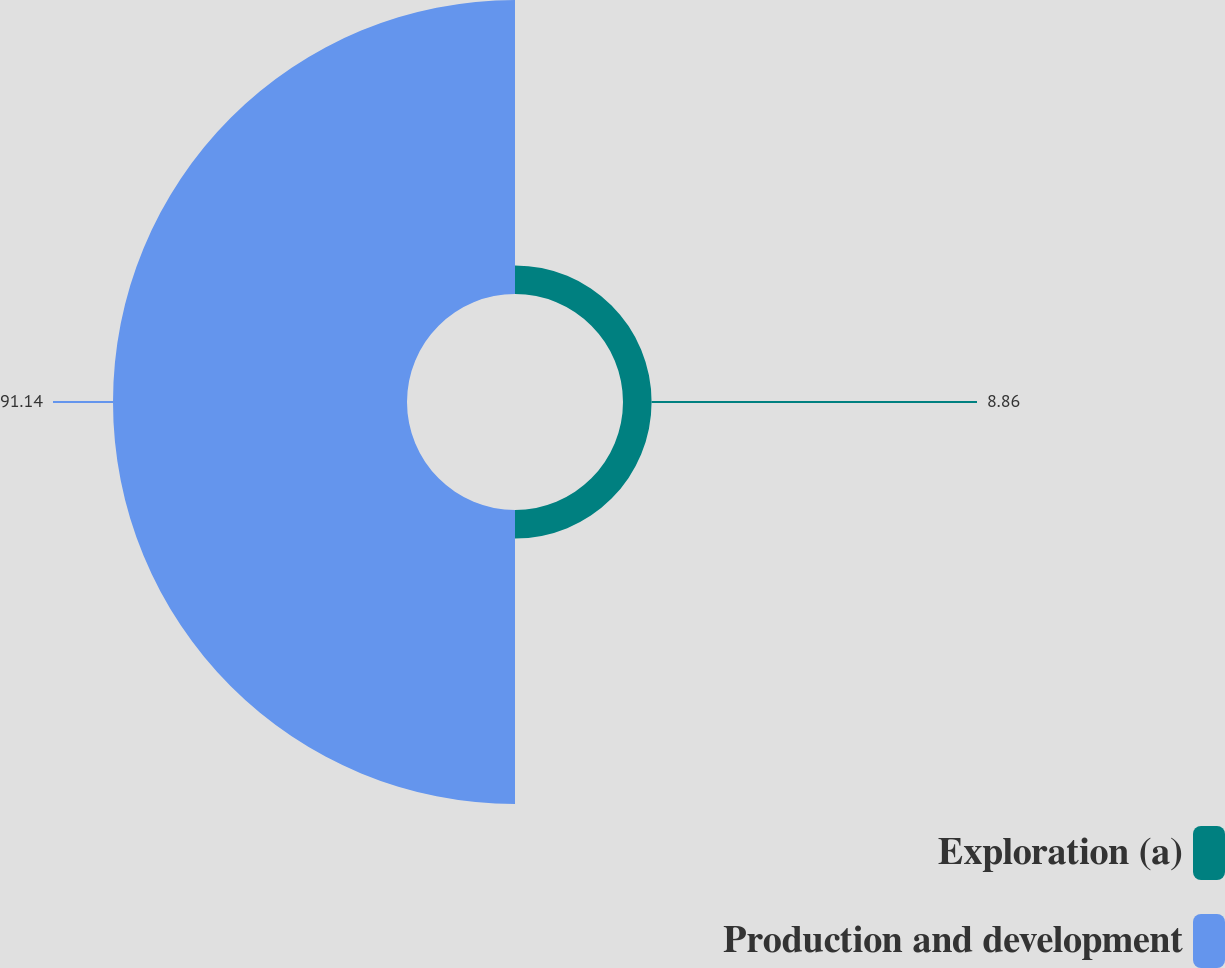<chart> <loc_0><loc_0><loc_500><loc_500><pie_chart><fcel>Exploration (a)<fcel>Production and development<nl><fcel>8.86%<fcel>91.14%<nl></chart> 